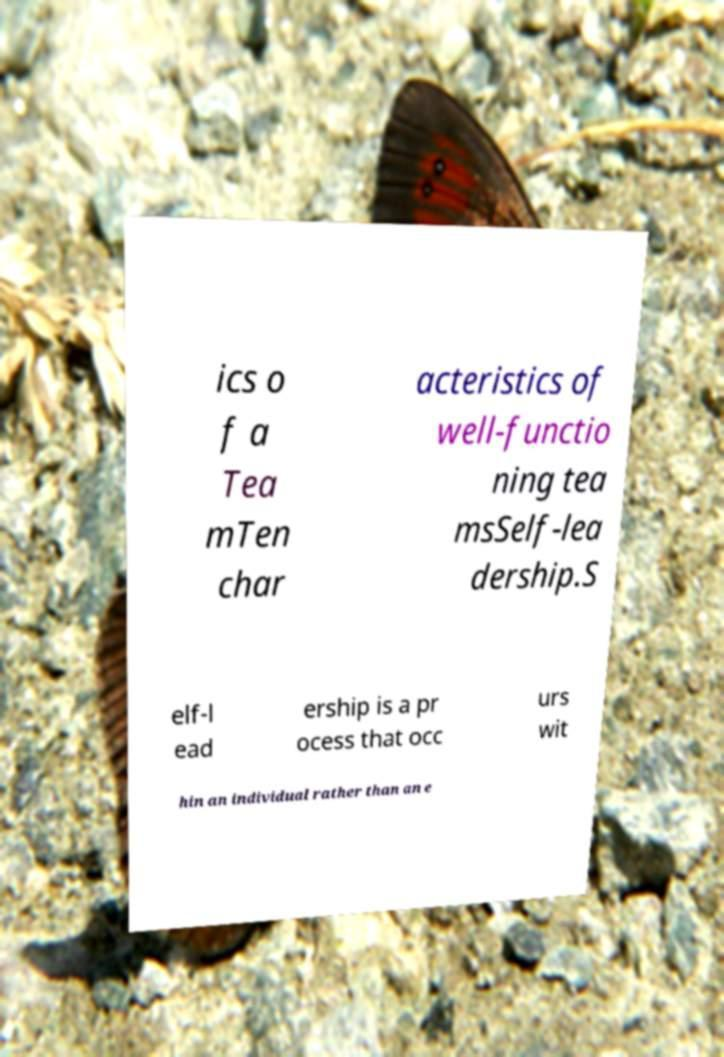Could you assist in decoding the text presented in this image and type it out clearly? ics o f a Tea mTen char acteristics of well-functio ning tea msSelf-lea dership.S elf-l ead ership is a pr ocess that occ urs wit hin an individual rather than an e 